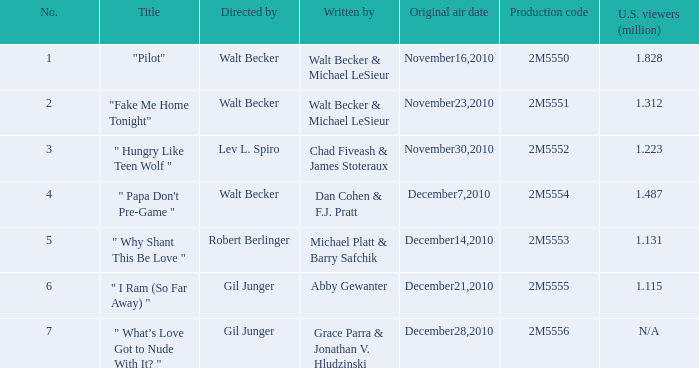What is the count of million american viewers who viewed "fake me home tonight"? 1.312. 